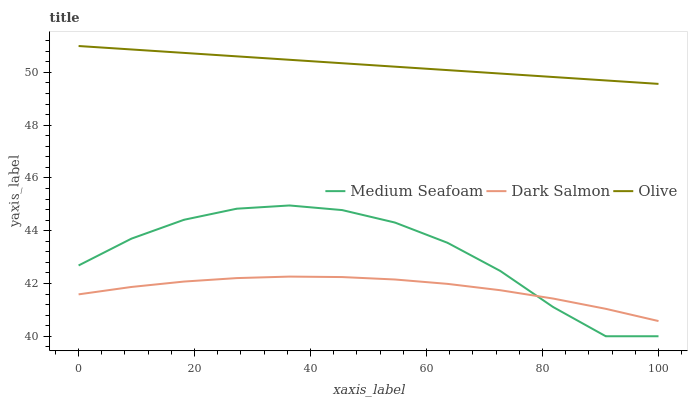Does Dark Salmon have the minimum area under the curve?
Answer yes or no. Yes. Does Olive have the maximum area under the curve?
Answer yes or no. Yes. Does Medium Seafoam have the minimum area under the curve?
Answer yes or no. No. Does Medium Seafoam have the maximum area under the curve?
Answer yes or no. No. Is Olive the smoothest?
Answer yes or no. Yes. Is Medium Seafoam the roughest?
Answer yes or no. Yes. Is Dark Salmon the smoothest?
Answer yes or no. No. Is Dark Salmon the roughest?
Answer yes or no. No. Does Medium Seafoam have the lowest value?
Answer yes or no. Yes. Does Dark Salmon have the lowest value?
Answer yes or no. No. Does Olive have the highest value?
Answer yes or no. Yes. Does Medium Seafoam have the highest value?
Answer yes or no. No. Is Medium Seafoam less than Olive?
Answer yes or no. Yes. Is Olive greater than Dark Salmon?
Answer yes or no. Yes. Does Dark Salmon intersect Medium Seafoam?
Answer yes or no. Yes. Is Dark Salmon less than Medium Seafoam?
Answer yes or no. No. Is Dark Salmon greater than Medium Seafoam?
Answer yes or no. No. Does Medium Seafoam intersect Olive?
Answer yes or no. No. 